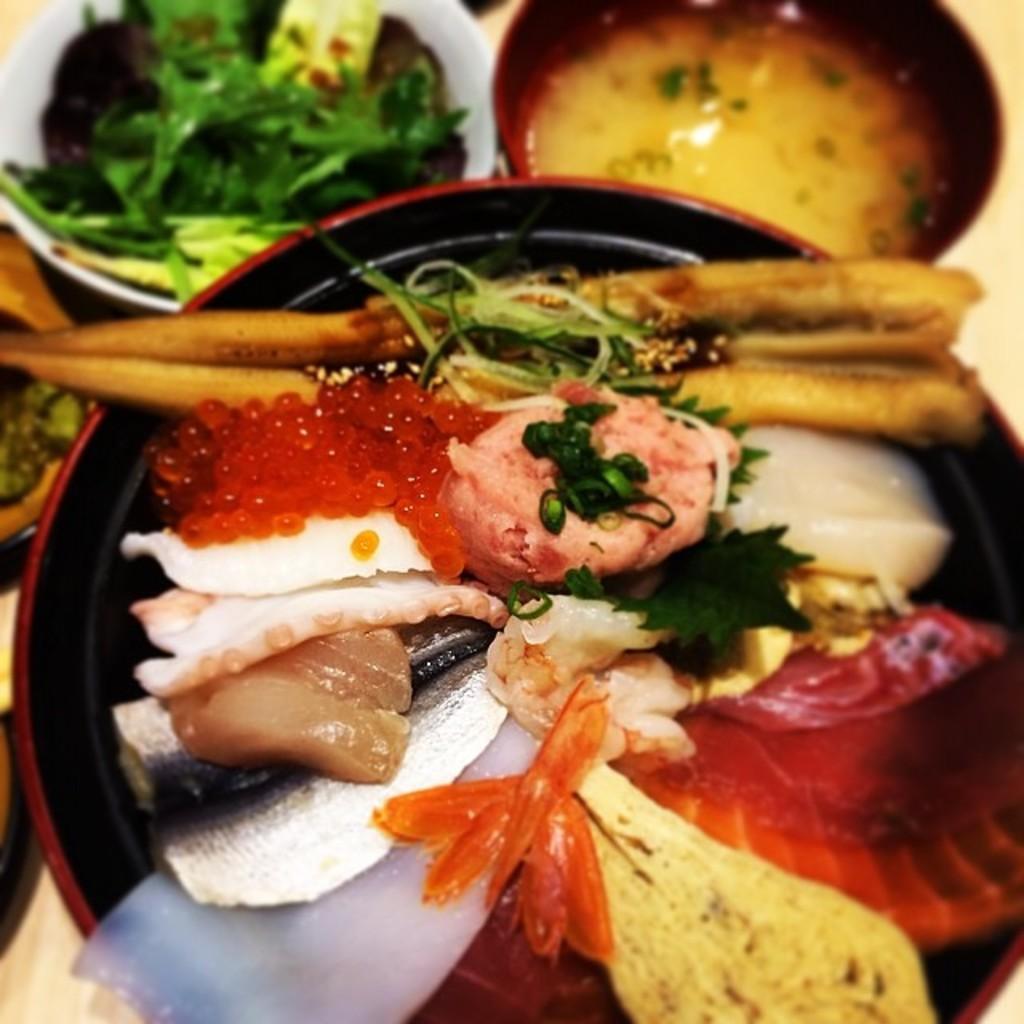Could you give a brief overview of what you see in this image? In this image I can see the food with bowls. I can see the bowls are in white, red and black color. The food is colorful. These are on the cream color surface. 